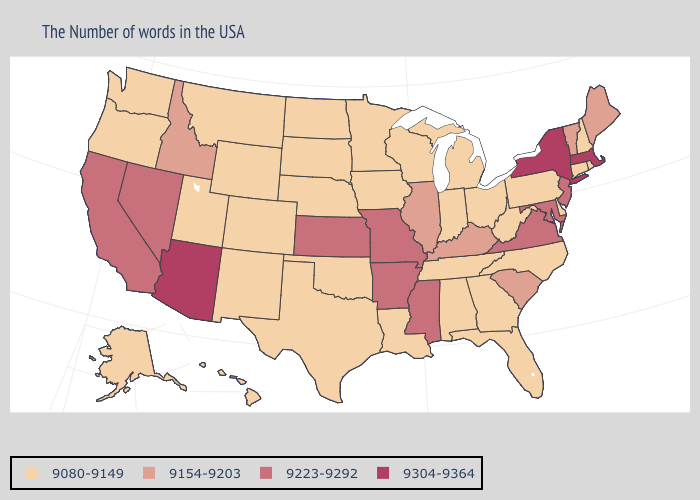What is the value of New Jersey?
Short answer required. 9223-9292. Name the states that have a value in the range 9154-9203?
Answer briefly. Maine, Vermont, South Carolina, Kentucky, Illinois, Idaho. Does Arizona have the highest value in the USA?
Short answer required. Yes. Name the states that have a value in the range 9223-9292?
Quick response, please. New Jersey, Maryland, Virginia, Mississippi, Missouri, Arkansas, Kansas, Nevada, California. Does the first symbol in the legend represent the smallest category?
Be succinct. Yes. Does the map have missing data?
Give a very brief answer. No. How many symbols are there in the legend?
Short answer required. 4. Name the states that have a value in the range 9304-9364?
Keep it brief. Massachusetts, New York, Arizona. Name the states that have a value in the range 9304-9364?
Write a very short answer. Massachusetts, New York, Arizona. What is the value of Iowa?
Give a very brief answer. 9080-9149. Does New Mexico have the same value as Nevada?
Concise answer only. No. Is the legend a continuous bar?
Keep it brief. No. What is the value of Kentucky?
Be succinct. 9154-9203. Among the states that border Delaware , does New Jersey have the lowest value?
Keep it brief. No. What is the highest value in the MidWest ?
Concise answer only. 9223-9292. 